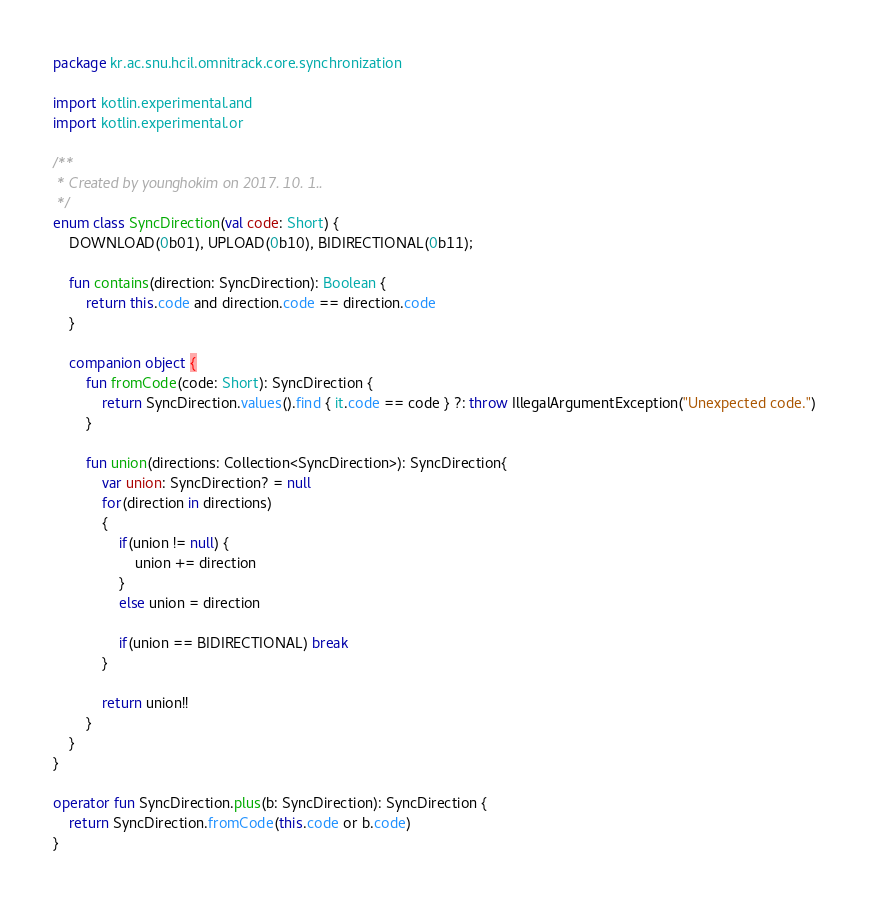<code> <loc_0><loc_0><loc_500><loc_500><_Kotlin_>package kr.ac.snu.hcil.omnitrack.core.synchronization

import kotlin.experimental.and
import kotlin.experimental.or

/**
 * Created by younghokim on 2017. 10. 1..
 */
enum class SyncDirection(val code: Short) {
    DOWNLOAD(0b01), UPLOAD(0b10), BIDIRECTIONAL(0b11);

    fun contains(direction: SyncDirection): Boolean {
        return this.code and direction.code == direction.code
    }

    companion object {
        fun fromCode(code: Short): SyncDirection {
            return SyncDirection.values().find { it.code == code } ?: throw IllegalArgumentException("Unexpected code.")
        }

        fun union(directions: Collection<SyncDirection>): SyncDirection{
            var union: SyncDirection? = null
            for(direction in directions)
            {
                if(union != null) {
                    union += direction
                }
                else union = direction

                if(union == BIDIRECTIONAL) break
            }

            return union!!
        }
    }
}

operator fun SyncDirection.plus(b: SyncDirection): SyncDirection {
    return SyncDirection.fromCode(this.code or b.code)
}</code> 